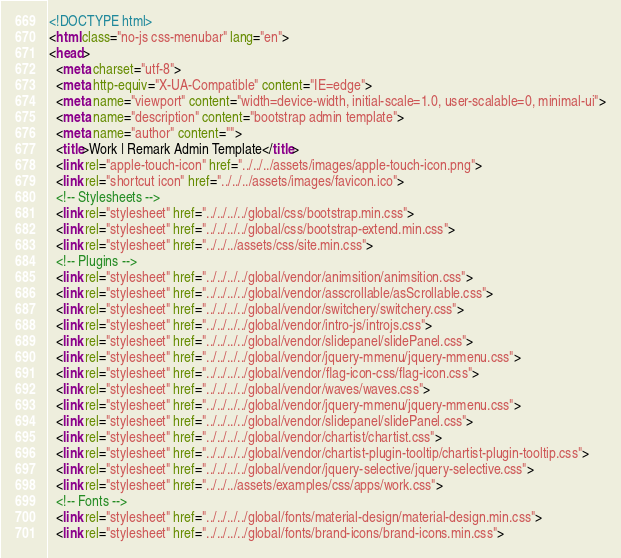<code> <loc_0><loc_0><loc_500><loc_500><_HTML_><!DOCTYPE html>
<html class="no-js css-menubar" lang="en">
<head>
  <meta charset="utf-8">
  <meta http-equiv="X-UA-Compatible" content="IE=edge">
  <meta name="viewport" content="width=device-width, initial-scale=1.0, user-scalable=0, minimal-ui">
  <meta name="description" content="bootstrap admin template">
  <meta name="author" content="">
  <title>Work | Remark Admin Template</title>
  <link rel="apple-touch-icon" href="../../../assets/images/apple-touch-icon.png">
  <link rel="shortcut icon" href="../../../assets/images/favicon.ico">
  <!-- Stylesheets -->
  <link rel="stylesheet" href="../../../../global/css/bootstrap.min.css">
  <link rel="stylesheet" href="../../../../global/css/bootstrap-extend.min.css">
  <link rel="stylesheet" href="../../../assets/css/site.min.css">
  <!-- Plugins -->
  <link rel="stylesheet" href="../../../../global/vendor/animsition/animsition.css">
  <link rel="stylesheet" href="../../../../global/vendor/asscrollable/asScrollable.css">
  <link rel="stylesheet" href="../../../../global/vendor/switchery/switchery.css">
  <link rel="stylesheet" href="../../../../global/vendor/intro-js/introjs.css">
  <link rel="stylesheet" href="../../../../global/vendor/slidepanel/slidePanel.css">
  <link rel="stylesheet" href="../../../../global/vendor/jquery-mmenu/jquery-mmenu.css">
  <link rel="stylesheet" href="../../../../global/vendor/flag-icon-css/flag-icon.css">
  <link rel="stylesheet" href="../../../../global/vendor/waves/waves.css">
  <link rel="stylesheet" href="../../../../global/vendor/jquery-mmenu/jquery-mmenu.css">
  <link rel="stylesheet" href="../../../../global/vendor/slidepanel/slidePanel.css">
  <link rel="stylesheet" href="../../../../global/vendor/chartist/chartist.css">
  <link rel="stylesheet" href="../../../../global/vendor/chartist-plugin-tooltip/chartist-plugin-tooltip.css">
  <link rel="stylesheet" href="../../../../global/vendor/jquery-selective/jquery-selective.css">
  <link rel="stylesheet" href="../../../assets/examples/css/apps/work.css">
  <!-- Fonts -->
  <link rel="stylesheet" href="../../../../global/fonts/material-design/material-design.min.css">
  <link rel="stylesheet" href="../../../../global/fonts/brand-icons/brand-icons.min.css"></code> 